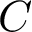Convert formula to latex. <formula><loc_0><loc_0><loc_500><loc_500>C</formula> 